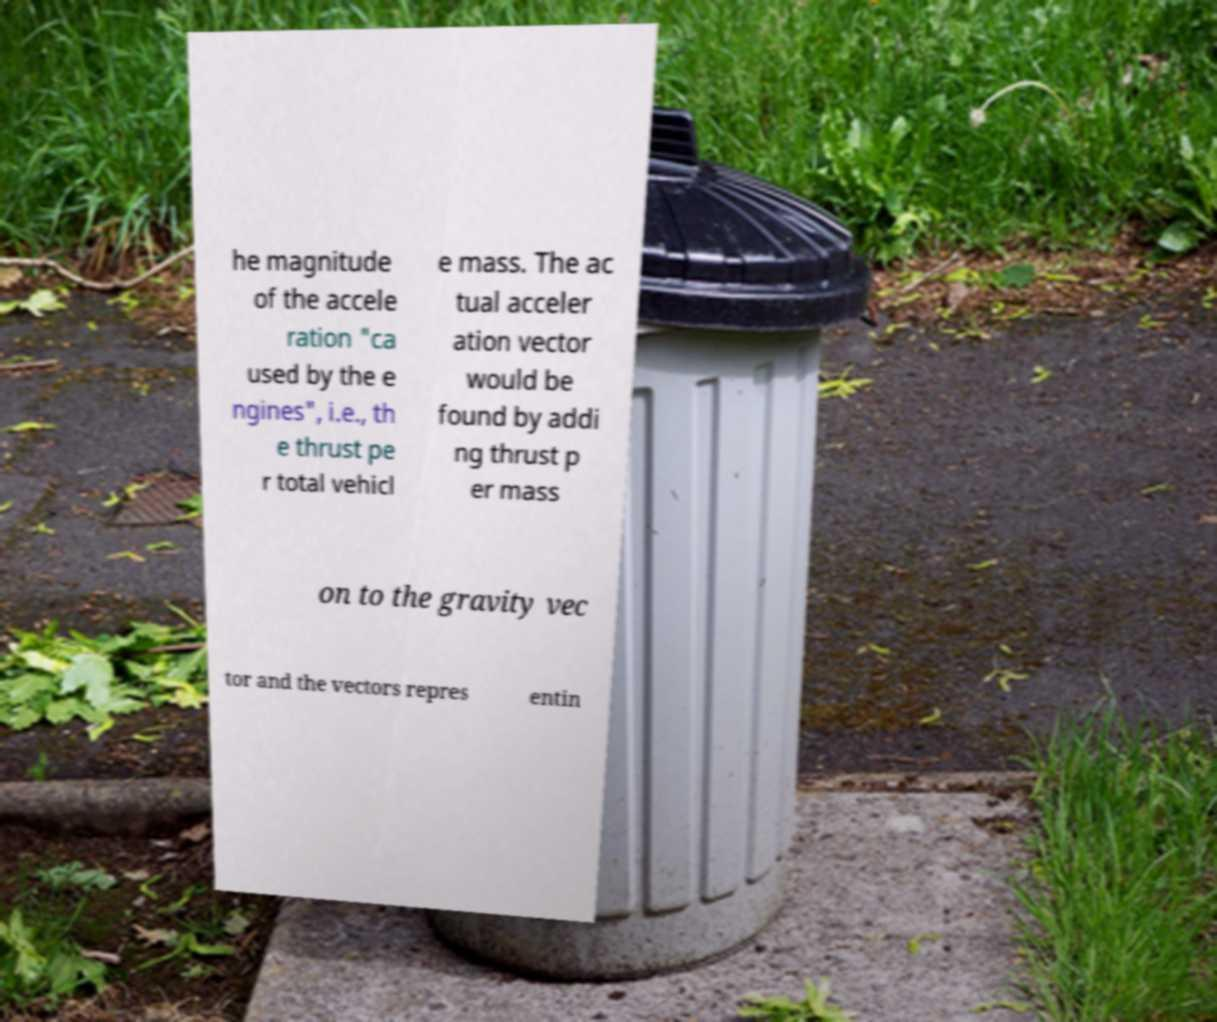There's text embedded in this image that I need extracted. Can you transcribe it verbatim? he magnitude of the accele ration "ca used by the e ngines", i.e., th e thrust pe r total vehicl e mass. The ac tual acceler ation vector would be found by addi ng thrust p er mass on to the gravity vec tor and the vectors repres entin 